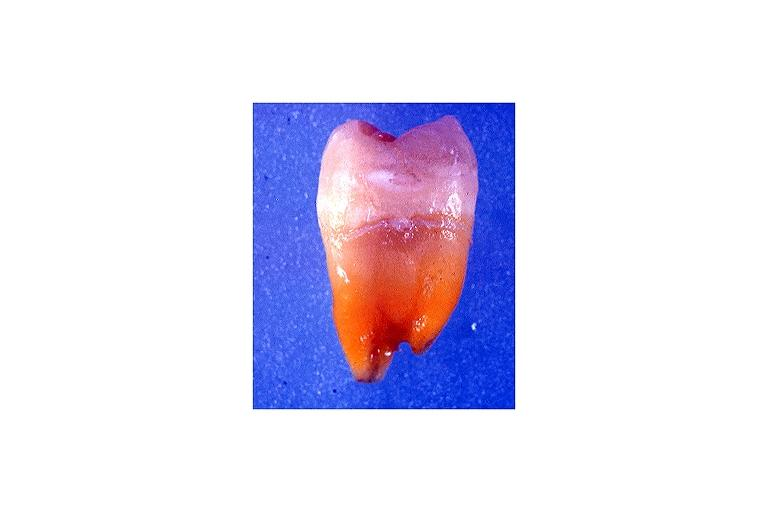what induced discoloration?
Answer the question using a single word or phrase. Tetracycline 